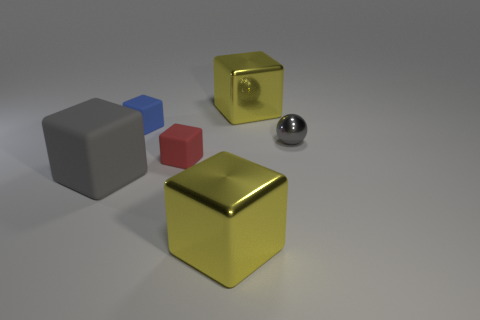Are there any green rubber balls of the same size as the blue rubber block?
Offer a terse response. No. There is a small block that is made of the same material as the red thing; what color is it?
Your response must be concise. Blue. There is a tiny thing that is behind the small metallic object; how many large yellow shiny cubes are on the left side of it?
Provide a succinct answer. 0. The block that is right of the small red rubber thing and behind the gray sphere is made of what material?
Keep it short and to the point. Metal. Is the shape of the gray thing that is behind the red object the same as  the gray rubber thing?
Your response must be concise. No. Is the number of yellow shiny things less than the number of big cyan metallic things?
Your answer should be very brief. No. How many large shiny blocks are the same color as the large rubber block?
Offer a terse response. 0. There is a big block that is the same color as the tiny metal thing; what is its material?
Give a very brief answer. Rubber. There is a big rubber cube; is it the same color as the shiny cube in front of the large rubber thing?
Your answer should be compact. No. Is the number of yellow spheres greater than the number of large gray cubes?
Your answer should be very brief. No. 